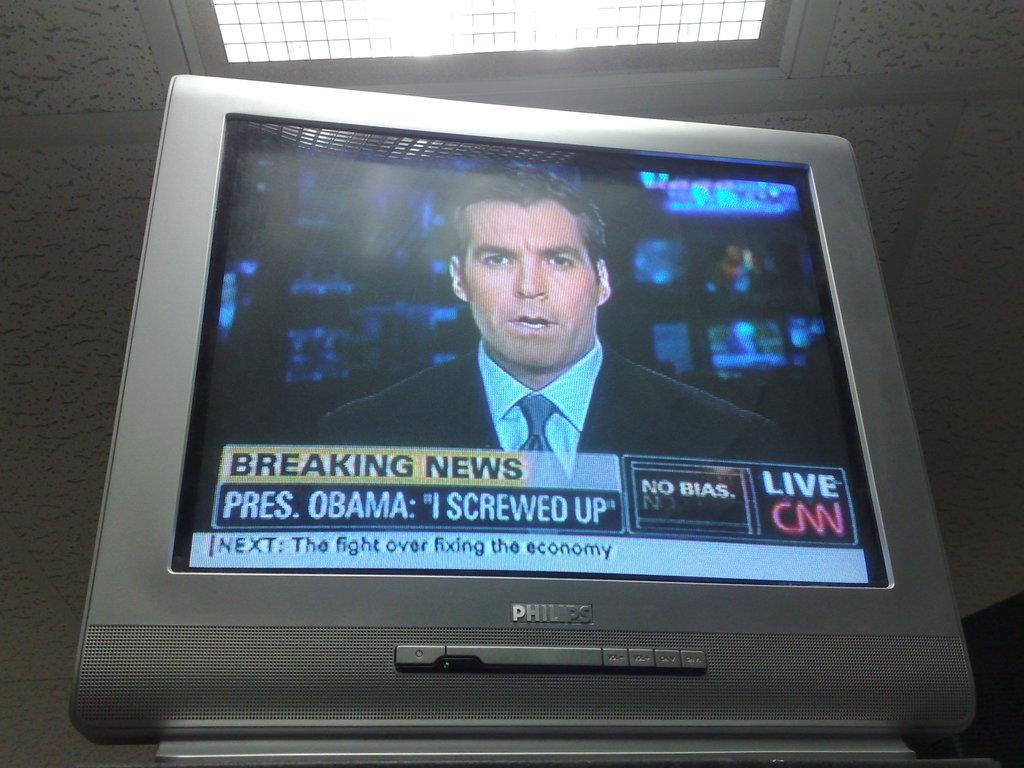What is the name of the president in the newscast?
Your answer should be compact. Obama. Who screwed up?
Offer a very short reply. Obama. 